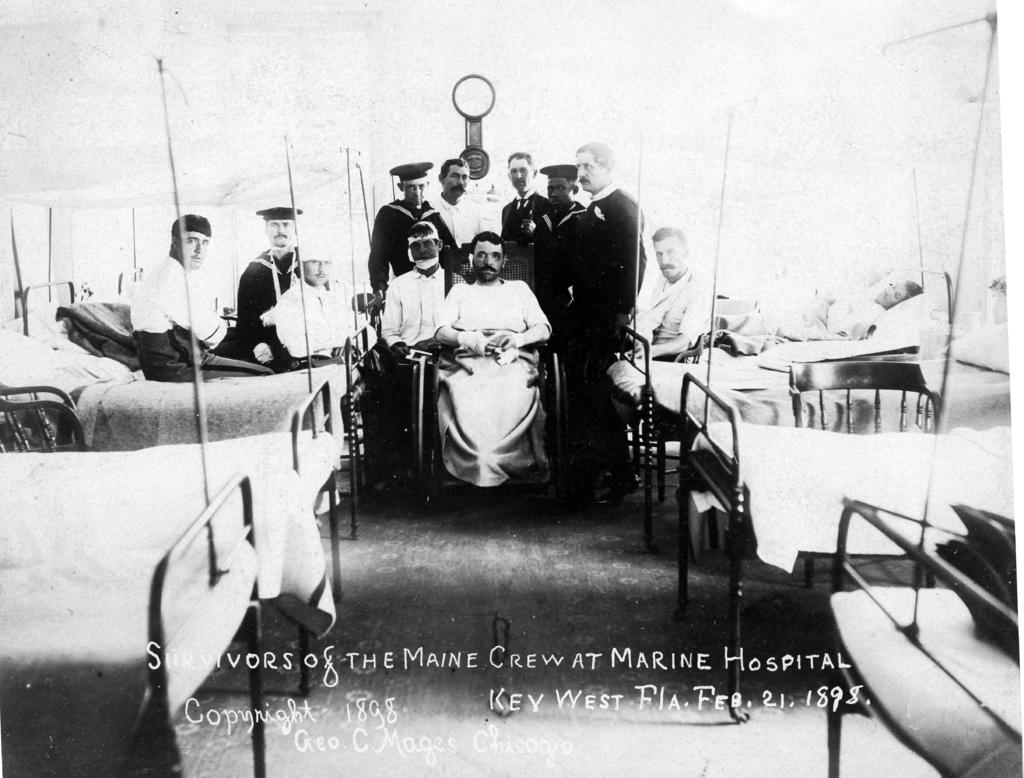What are the people in the image doing on the bed? Some people are sitting on the bed, while others are sleeping on it. What is the position of the people in the wheelchair in the image? There are people sitting on a wheelchair in the image. What is the location of the people who are not on the bed or in the wheelchair? Some people are standing on the floor in the image. Can you describe an object visible in the background of the image? There is a watch visible in the background of the image. What type of cracker is being used to observe the earthquake in the image? There is no earthquake or cracker present in the image. What is the observation being made about the people sitting on the bed? The conversation does not mention any observation being made about the people sitting on the bed. 